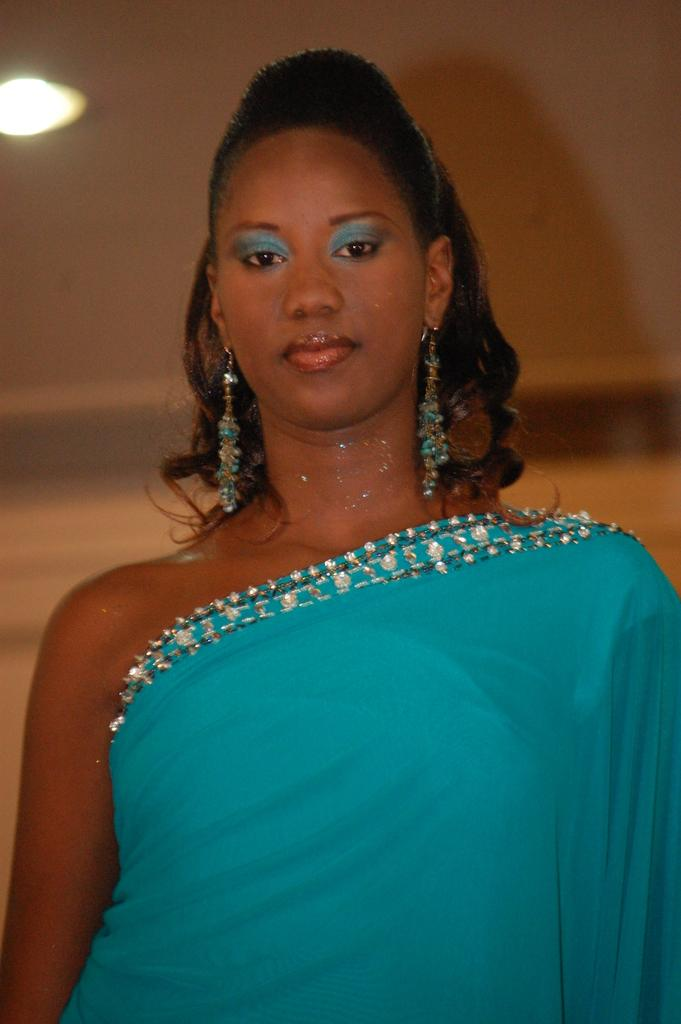Who is the main subject in the image? There is a woman standing in the center of the image. What can be seen in the background of the image? There is a wall in the background of the image. Can you describe the lighting in the image? There is light visible in the image. What type of exchange is taking place between the woman and the bears in the image? There are no bears present in the image, so no exchange can be observed. 